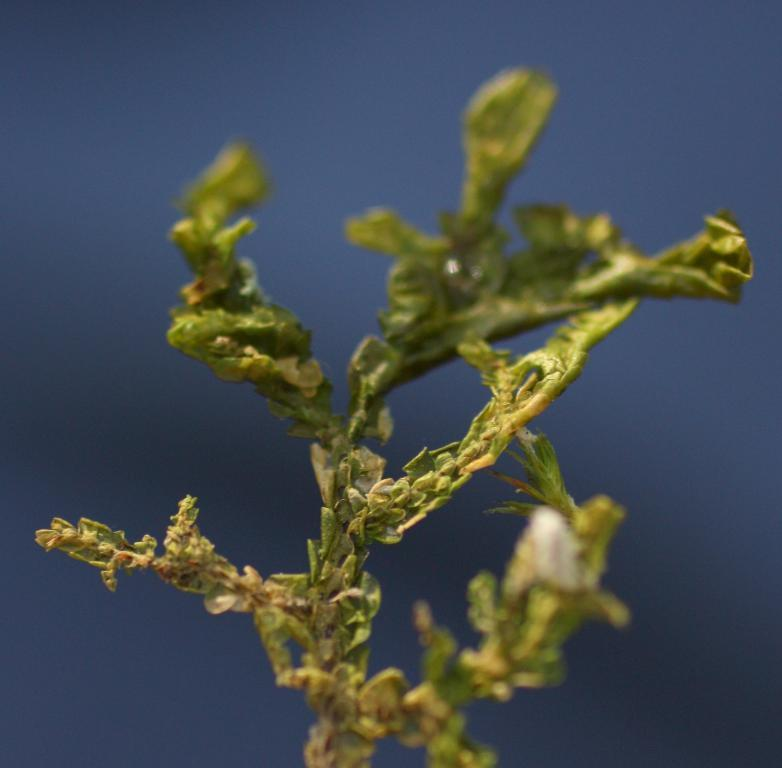What type of living organism can be seen in the image? There is a plant in the image. What type of marble is used to decorate the pot of the plant in the image? There is no mention of marble or any decorative elements in the image; it only states that there is a plant. 